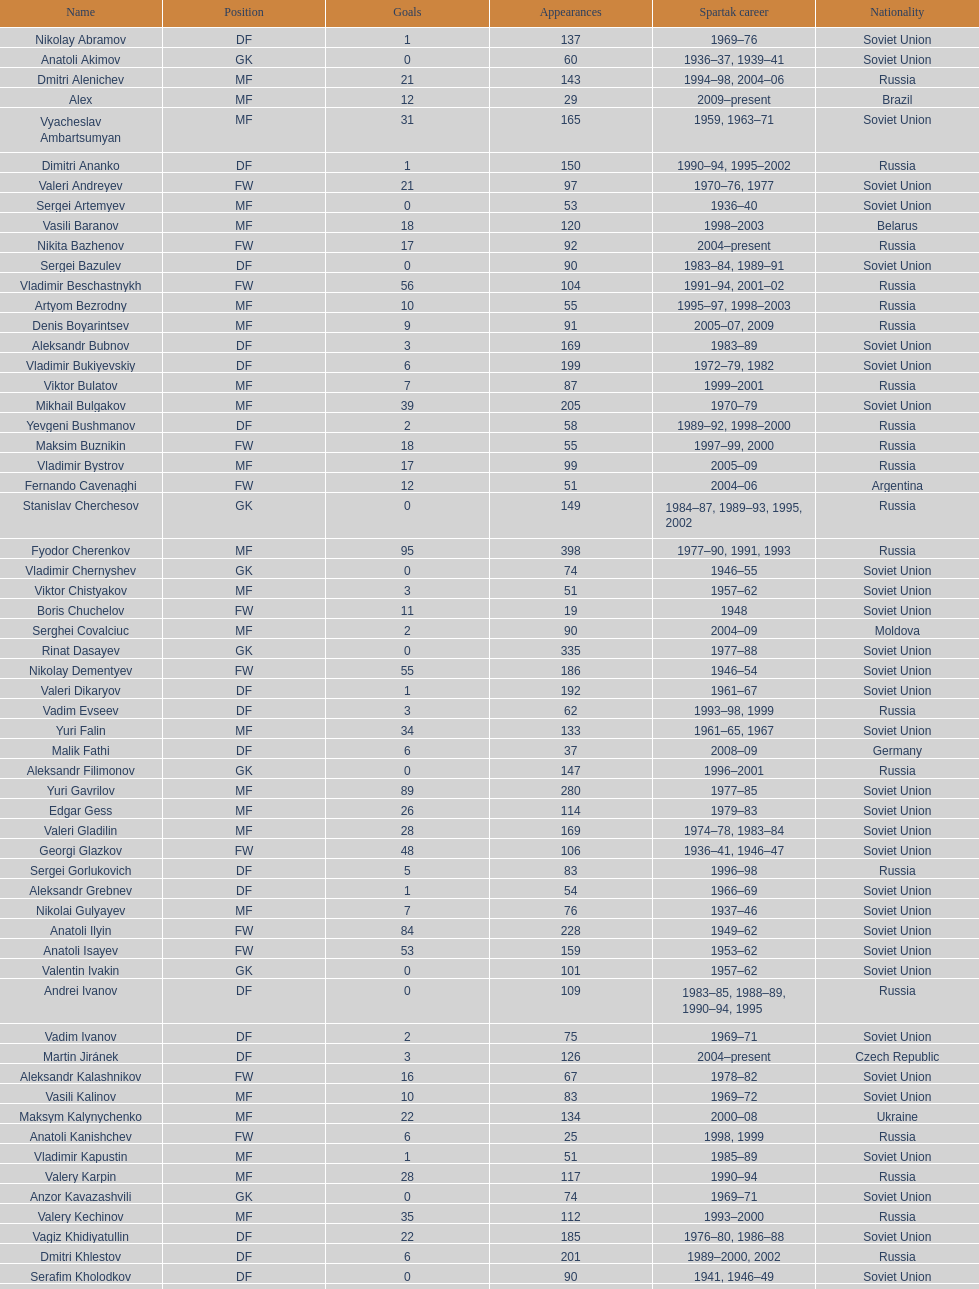How many players had at least 20 league goals scored? 56. 